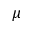<formula> <loc_0><loc_0><loc_500><loc_500>\mu</formula> 